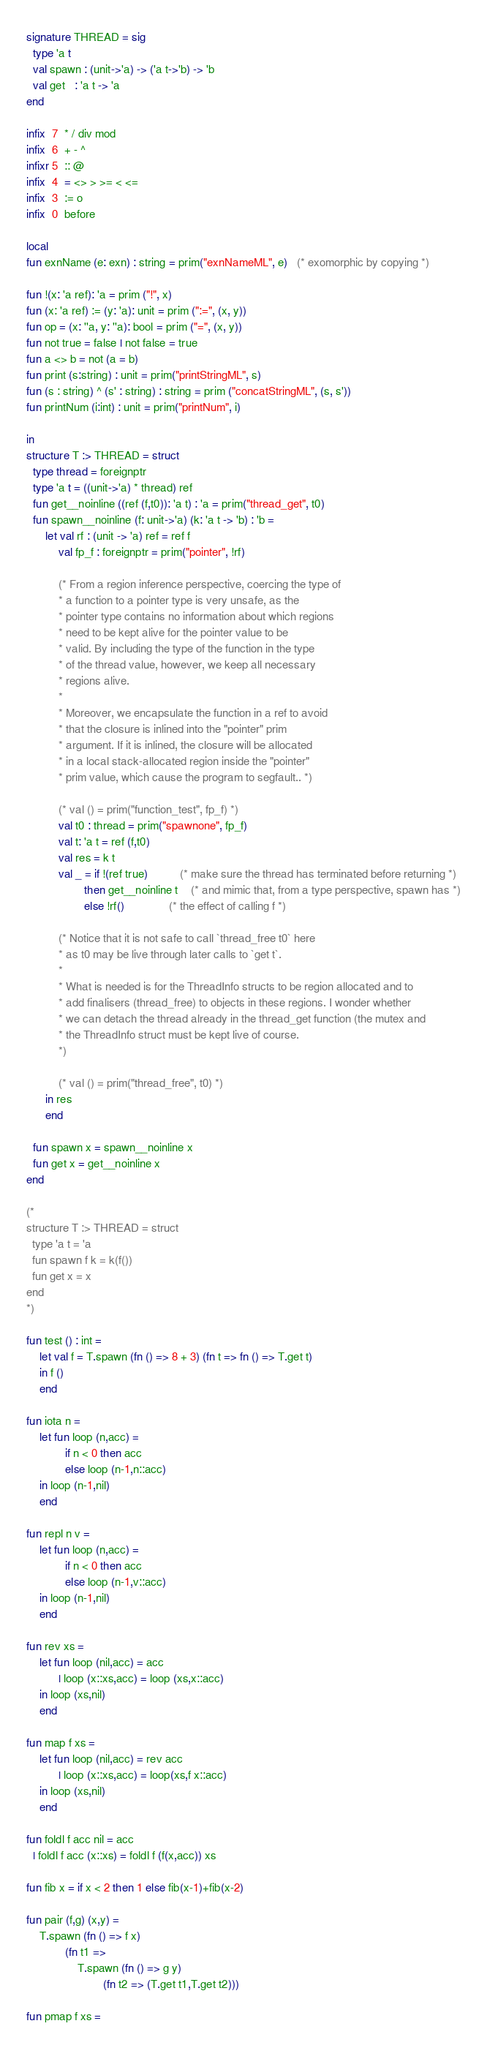<code> <loc_0><loc_0><loc_500><loc_500><_SML_>signature THREAD = sig
  type 'a t
  val spawn : (unit->'a) -> ('a t->'b) -> 'b
  val get   : 'a t -> 'a
end

infix  7  * / div mod
infix  6  + - ^
infixr 5  :: @
infix  4  = <> > >= < <=
infix  3  := o
infix  0  before

local
fun exnName (e: exn) : string = prim("exnNameML", e)   (* exomorphic by copying *)

fun !(x: 'a ref): 'a = prim ("!", x)
fun (x: 'a ref) := (y: 'a): unit = prim (":=", (x, y))
fun op = (x: ''a, y: ''a): bool = prim ("=", (x, y))
fun not true = false | not false = true
fun a <> b = not (a = b)
fun print (s:string) : unit = prim("printStringML", s)
fun (s : string) ^ (s' : string) : string = prim ("concatStringML", (s, s'))
fun printNum (i:int) : unit = prim("printNum", i)

in
structure T :> THREAD = struct
  type thread = foreignptr
  type 'a t = ((unit->'a) * thread) ref
  fun get__noinline ((ref (f,t0)): 'a t) : 'a = prim("thread_get", t0)
  fun spawn__noinline (f: unit->'a) (k: 'a t -> 'b) : 'b =
      let val rf : (unit -> 'a) ref = ref f
          val fp_f : foreignptr = prim("pointer", !rf)

          (* From a region inference perspective, coercing the type of
           * a function to a pointer type is very unsafe, as the
           * pointer type contains no information about which regions
           * need to be kept alive for the pointer value to be
           * valid. By including the type of the function in the type
           * of the thread value, however, we keep all necessary
           * regions alive.
           *
           * Moreover, we encapsulate the function in a ref to avoid
           * that the closure is inlined into the "pointer" prim
           * argument. If it is inlined, the closure will be allocated
           * in a local stack-allocated region inside the "pointer"
           * prim value, which cause the program to segfault.. *)

          (* val () = prim("function_test", fp_f) *)
          val t0 : thread = prim("spawnone", fp_f)
          val t: 'a t = ref (f,t0)
          val res = k t
          val _ = if !(ref true)          (* make sure the thread has terminated before returning *)
                  then get__noinline t    (* and mimic that, from a type perspective, spawn has *)
                  else !rf()              (* the effect of calling f *)

          (* Notice that it is not safe to call `thread_free t0` here
           * as t0 may be live through later calls to `get t`.
           *
           * What is needed is for the ThreadInfo structs to be region allocated and to
           * add finalisers (thread_free) to objects in these regions. I wonder whether
           * we can detach the thread already in the thread_get function (the mutex and
           * the ThreadInfo struct must be kept live of course.
           *)

          (* val () = prim("thread_free", t0) *)
      in res
      end

  fun spawn x = spawn__noinline x
  fun get x = get__noinline x
end

(*
structure T :> THREAD = struct
  type 'a t = 'a
  fun spawn f k = k(f())
  fun get x = x
end
*)

fun test () : int =
    let val f = T.spawn (fn () => 8 + 3) (fn t => fn () => T.get t)
    in f ()
    end

fun iota n =
    let fun loop (n,acc) =
            if n < 0 then acc
            else loop (n-1,n::acc)
    in loop (n-1,nil)
    end

fun repl n v =
    let fun loop (n,acc) =
            if n < 0 then acc
            else loop (n-1,v::acc)
    in loop (n-1,nil)
    end

fun rev xs =
    let fun loop (nil,acc) = acc
          | loop (x::xs,acc) = loop (xs,x::acc)
    in loop (xs,nil)
    end

fun map f xs =
    let fun loop (nil,acc) = rev acc
          | loop (x::xs,acc) = loop(xs,f x::acc)
    in loop (xs,nil)
    end

fun foldl f acc nil = acc
  | foldl f acc (x::xs) = foldl f (f(x,acc)) xs

fun fib x = if x < 2 then 1 else fib(x-1)+fib(x-2)

fun pair (f,g) (x,y) =
    T.spawn (fn () => f x)
            (fn t1 =>
                T.spawn (fn () => g y)
                        (fn t2 => (T.get t1,T.get t2)))

fun pmap f xs =</code> 